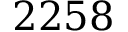<formula> <loc_0><loc_0><loc_500><loc_500>2 2 5 8</formula> 